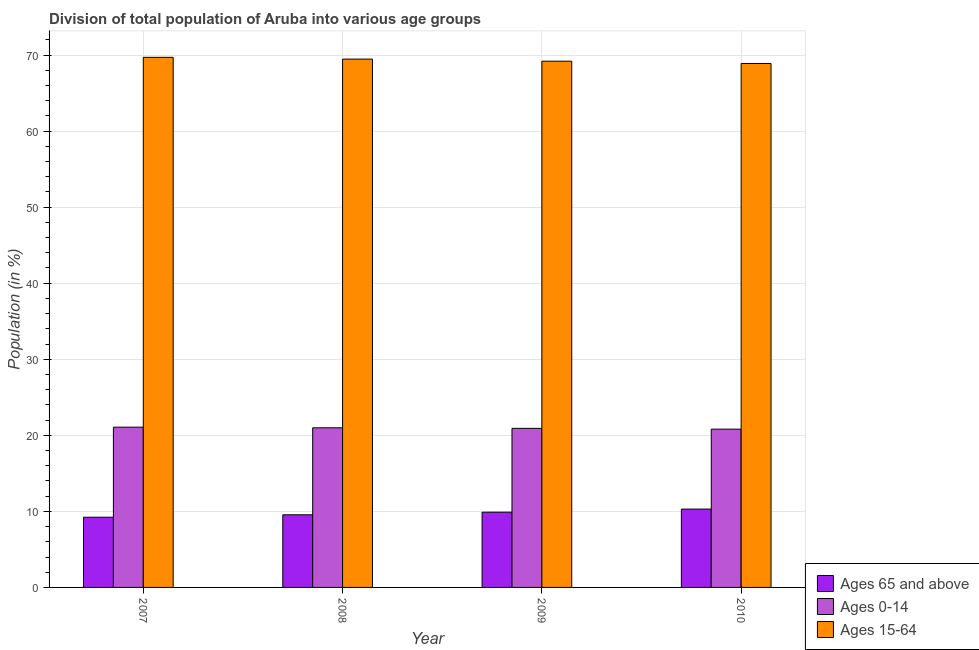How many different coloured bars are there?
Provide a succinct answer. 3. How many groups of bars are there?
Offer a very short reply. 4. How many bars are there on the 1st tick from the left?
Your response must be concise. 3. What is the percentage of population within the age-group 15-64 in 2009?
Provide a succinct answer. 69.19. Across all years, what is the maximum percentage of population within the age-group 0-14?
Ensure brevity in your answer.  21.07. Across all years, what is the minimum percentage of population within the age-group 0-14?
Your response must be concise. 20.81. In which year was the percentage of population within the age-group 15-64 minimum?
Offer a terse response. 2010. What is the total percentage of population within the age-group 0-14 in the graph?
Make the answer very short. 83.78. What is the difference between the percentage of population within the age-group 15-64 in 2008 and that in 2009?
Ensure brevity in your answer.  0.28. What is the difference between the percentage of population within the age-group 0-14 in 2010 and the percentage of population within the age-group of 65 and above in 2007?
Keep it short and to the point. -0.26. What is the average percentage of population within the age-group 15-64 per year?
Your answer should be compact. 69.31. In the year 2010, what is the difference between the percentage of population within the age-group 0-14 and percentage of population within the age-group 15-64?
Offer a terse response. 0. In how many years, is the percentage of population within the age-group 0-14 greater than 68 %?
Give a very brief answer. 0. What is the ratio of the percentage of population within the age-group of 65 and above in 2007 to that in 2008?
Offer a terse response. 0.97. Is the percentage of population within the age-group 15-64 in 2007 less than that in 2010?
Keep it short and to the point. No. What is the difference between the highest and the second highest percentage of population within the age-group of 65 and above?
Ensure brevity in your answer.  0.4. What is the difference between the highest and the lowest percentage of population within the age-group 15-64?
Keep it short and to the point. 0.81. What does the 2nd bar from the left in 2009 represents?
Give a very brief answer. Ages 0-14. What does the 1st bar from the right in 2009 represents?
Make the answer very short. Ages 15-64. Is it the case that in every year, the sum of the percentage of population within the age-group of 65 and above and percentage of population within the age-group 0-14 is greater than the percentage of population within the age-group 15-64?
Your answer should be compact. No. Are all the bars in the graph horizontal?
Give a very brief answer. No. What is the difference between two consecutive major ticks on the Y-axis?
Offer a terse response. 10. Does the graph contain any zero values?
Keep it short and to the point. No. Does the graph contain grids?
Offer a very short reply. Yes. Where does the legend appear in the graph?
Provide a succinct answer. Bottom right. What is the title of the graph?
Keep it short and to the point. Division of total population of Aruba into various age groups
. Does "Czech Republic" appear as one of the legend labels in the graph?
Provide a succinct answer. No. What is the label or title of the Y-axis?
Make the answer very short. Population (in %). What is the Population (in %) in Ages 65 and above in 2007?
Provide a succinct answer. 9.23. What is the Population (in %) in Ages 0-14 in 2007?
Offer a terse response. 21.07. What is the Population (in %) in Ages 15-64 in 2007?
Keep it short and to the point. 69.7. What is the Population (in %) of Ages 65 and above in 2008?
Ensure brevity in your answer.  9.55. What is the Population (in %) of Ages 0-14 in 2008?
Provide a short and direct response. 20.99. What is the Population (in %) in Ages 15-64 in 2008?
Offer a very short reply. 69.46. What is the Population (in %) in Ages 65 and above in 2009?
Offer a terse response. 9.9. What is the Population (in %) of Ages 0-14 in 2009?
Ensure brevity in your answer.  20.91. What is the Population (in %) of Ages 15-64 in 2009?
Ensure brevity in your answer.  69.19. What is the Population (in %) of Ages 65 and above in 2010?
Ensure brevity in your answer.  10.3. What is the Population (in %) of Ages 0-14 in 2010?
Make the answer very short. 20.81. What is the Population (in %) in Ages 15-64 in 2010?
Keep it short and to the point. 68.89. Across all years, what is the maximum Population (in %) of Ages 65 and above?
Offer a very short reply. 10.3. Across all years, what is the maximum Population (in %) of Ages 0-14?
Offer a terse response. 21.07. Across all years, what is the maximum Population (in %) in Ages 15-64?
Offer a terse response. 69.7. Across all years, what is the minimum Population (in %) in Ages 65 and above?
Provide a short and direct response. 9.23. Across all years, what is the minimum Population (in %) in Ages 0-14?
Your answer should be very brief. 20.81. Across all years, what is the minimum Population (in %) of Ages 15-64?
Offer a terse response. 68.89. What is the total Population (in %) in Ages 65 and above in the graph?
Provide a succinct answer. 38.97. What is the total Population (in %) of Ages 0-14 in the graph?
Provide a succinct answer. 83.78. What is the total Population (in %) of Ages 15-64 in the graph?
Ensure brevity in your answer.  277.24. What is the difference between the Population (in %) of Ages 65 and above in 2007 and that in 2008?
Keep it short and to the point. -0.32. What is the difference between the Population (in %) in Ages 0-14 in 2007 and that in 2008?
Provide a short and direct response. 0.09. What is the difference between the Population (in %) in Ages 15-64 in 2007 and that in 2008?
Offer a very short reply. 0.23. What is the difference between the Population (in %) of Ages 65 and above in 2007 and that in 2009?
Offer a terse response. -0.67. What is the difference between the Population (in %) in Ages 0-14 in 2007 and that in 2009?
Offer a very short reply. 0.16. What is the difference between the Population (in %) in Ages 15-64 in 2007 and that in 2009?
Provide a succinct answer. 0.51. What is the difference between the Population (in %) of Ages 65 and above in 2007 and that in 2010?
Provide a short and direct response. -1.07. What is the difference between the Population (in %) of Ages 0-14 in 2007 and that in 2010?
Your answer should be very brief. 0.26. What is the difference between the Population (in %) of Ages 15-64 in 2007 and that in 2010?
Keep it short and to the point. 0.81. What is the difference between the Population (in %) in Ages 65 and above in 2008 and that in 2009?
Make the answer very short. -0.35. What is the difference between the Population (in %) in Ages 0-14 in 2008 and that in 2009?
Keep it short and to the point. 0.07. What is the difference between the Population (in %) in Ages 15-64 in 2008 and that in 2009?
Keep it short and to the point. 0.28. What is the difference between the Population (in %) in Ages 65 and above in 2008 and that in 2010?
Offer a terse response. -0.75. What is the difference between the Population (in %) of Ages 0-14 in 2008 and that in 2010?
Provide a short and direct response. 0.18. What is the difference between the Population (in %) of Ages 15-64 in 2008 and that in 2010?
Offer a very short reply. 0.57. What is the difference between the Population (in %) in Ages 65 and above in 2009 and that in 2010?
Give a very brief answer. -0.4. What is the difference between the Population (in %) of Ages 0-14 in 2009 and that in 2010?
Offer a terse response. 0.11. What is the difference between the Population (in %) in Ages 15-64 in 2009 and that in 2010?
Provide a short and direct response. 0.3. What is the difference between the Population (in %) of Ages 65 and above in 2007 and the Population (in %) of Ages 0-14 in 2008?
Offer a very short reply. -11.76. What is the difference between the Population (in %) in Ages 65 and above in 2007 and the Population (in %) in Ages 15-64 in 2008?
Give a very brief answer. -60.23. What is the difference between the Population (in %) in Ages 0-14 in 2007 and the Population (in %) in Ages 15-64 in 2008?
Provide a succinct answer. -48.39. What is the difference between the Population (in %) in Ages 65 and above in 2007 and the Population (in %) in Ages 0-14 in 2009?
Give a very brief answer. -11.68. What is the difference between the Population (in %) of Ages 65 and above in 2007 and the Population (in %) of Ages 15-64 in 2009?
Give a very brief answer. -59.96. What is the difference between the Population (in %) in Ages 0-14 in 2007 and the Population (in %) in Ages 15-64 in 2009?
Provide a succinct answer. -48.12. What is the difference between the Population (in %) in Ages 65 and above in 2007 and the Population (in %) in Ages 0-14 in 2010?
Your answer should be very brief. -11.58. What is the difference between the Population (in %) of Ages 65 and above in 2007 and the Population (in %) of Ages 15-64 in 2010?
Provide a succinct answer. -59.66. What is the difference between the Population (in %) in Ages 0-14 in 2007 and the Population (in %) in Ages 15-64 in 2010?
Offer a very short reply. -47.82. What is the difference between the Population (in %) in Ages 65 and above in 2008 and the Population (in %) in Ages 0-14 in 2009?
Your response must be concise. -11.37. What is the difference between the Population (in %) in Ages 65 and above in 2008 and the Population (in %) in Ages 15-64 in 2009?
Your answer should be very brief. -59.64. What is the difference between the Population (in %) in Ages 0-14 in 2008 and the Population (in %) in Ages 15-64 in 2009?
Keep it short and to the point. -48.2. What is the difference between the Population (in %) of Ages 65 and above in 2008 and the Population (in %) of Ages 0-14 in 2010?
Your response must be concise. -11.26. What is the difference between the Population (in %) in Ages 65 and above in 2008 and the Population (in %) in Ages 15-64 in 2010?
Give a very brief answer. -59.34. What is the difference between the Population (in %) in Ages 0-14 in 2008 and the Population (in %) in Ages 15-64 in 2010?
Your answer should be compact. -47.9. What is the difference between the Population (in %) of Ages 65 and above in 2009 and the Population (in %) of Ages 0-14 in 2010?
Ensure brevity in your answer.  -10.91. What is the difference between the Population (in %) of Ages 65 and above in 2009 and the Population (in %) of Ages 15-64 in 2010?
Offer a very short reply. -58.99. What is the difference between the Population (in %) of Ages 0-14 in 2009 and the Population (in %) of Ages 15-64 in 2010?
Offer a terse response. -47.98. What is the average Population (in %) of Ages 65 and above per year?
Your answer should be very brief. 9.74. What is the average Population (in %) of Ages 0-14 per year?
Offer a very short reply. 20.95. What is the average Population (in %) in Ages 15-64 per year?
Offer a very short reply. 69.31. In the year 2007, what is the difference between the Population (in %) in Ages 65 and above and Population (in %) in Ages 0-14?
Provide a succinct answer. -11.84. In the year 2007, what is the difference between the Population (in %) in Ages 65 and above and Population (in %) in Ages 15-64?
Ensure brevity in your answer.  -60.47. In the year 2007, what is the difference between the Population (in %) of Ages 0-14 and Population (in %) of Ages 15-64?
Offer a very short reply. -48.63. In the year 2008, what is the difference between the Population (in %) of Ages 65 and above and Population (in %) of Ages 0-14?
Your answer should be very brief. -11.44. In the year 2008, what is the difference between the Population (in %) in Ages 65 and above and Population (in %) in Ages 15-64?
Your answer should be very brief. -59.92. In the year 2008, what is the difference between the Population (in %) of Ages 0-14 and Population (in %) of Ages 15-64?
Your answer should be very brief. -48.48. In the year 2009, what is the difference between the Population (in %) in Ages 65 and above and Population (in %) in Ages 0-14?
Ensure brevity in your answer.  -11.02. In the year 2009, what is the difference between the Population (in %) of Ages 65 and above and Population (in %) of Ages 15-64?
Your answer should be compact. -59.29. In the year 2009, what is the difference between the Population (in %) in Ages 0-14 and Population (in %) in Ages 15-64?
Offer a very short reply. -48.27. In the year 2010, what is the difference between the Population (in %) of Ages 65 and above and Population (in %) of Ages 0-14?
Offer a very short reply. -10.51. In the year 2010, what is the difference between the Population (in %) in Ages 65 and above and Population (in %) in Ages 15-64?
Give a very brief answer. -58.59. In the year 2010, what is the difference between the Population (in %) in Ages 0-14 and Population (in %) in Ages 15-64?
Ensure brevity in your answer.  -48.08. What is the ratio of the Population (in %) of Ages 65 and above in 2007 to that in 2008?
Your response must be concise. 0.97. What is the ratio of the Population (in %) of Ages 15-64 in 2007 to that in 2008?
Your response must be concise. 1. What is the ratio of the Population (in %) in Ages 65 and above in 2007 to that in 2009?
Make the answer very short. 0.93. What is the ratio of the Population (in %) in Ages 0-14 in 2007 to that in 2009?
Provide a succinct answer. 1.01. What is the ratio of the Population (in %) of Ages 15-64 in 2007 to that in 2009?
Provide a short and direct response. 1.01. What is the ratio of the Population (in %) in Ages 65 and above in 2007 to that in 2010?
Provide a succinct answer. 0.9. What is the ratio of the Population (in %) of Ages 0-14 in 2007 to that in 2010?
Make the answer very short. 1.01. What is the ratio of the Population (in %) in Ages 15-64 in 2007 to that in 2010?
Give a very brief answer. 1.01. What is the ratio of the Population (in %) of Ages 65 and above in 2008 to that in 2009?
Your answer should be very brief. 0.96. What is the ratio of the Population (in %) of Ages 0-14 in 2008 to that in 2009?
Provide a succinct answer. 1. What is the ratio of the Population (in %) in Ages 65 and above in 2008 to that in 2010?
Your answer should be very brief. 0.93. What is the ratio of the Population (in %) of Ages 0-14 in 2008 to that in 2010?
Your response must be concise. 1.01. What is the ratio of the Population (in %) in Ages 15-64 in 2008 to that in 2010?
Provide a short and direct response. 1.01. What is the ratio of the Population (in %) of Ages 65 and above in 2009 to that in 2010?
Keep it short and to the point. 0.96. What is the ratio of the Population (in %) of Ages 0-14 in 2009 to that in 2010?
Provide a succinct answer. 1.01. What is the ratio of the Population (in %) of Ages 15-64 in 2009 to that in 2010?
Your answer should be very brief. 1. What is the difference between the highest and the second highest Population (in %) of Ages 65 and above?
Offer a very short reply. 0.4. What is the difference between the highest and the second highest Population (in %) of Ages 0-14?
Provide a short and direct response. 0.09. What is the difference between the highest and the second highest Population (in %) in Ages 15-64?
Offer a terse response. 0.23. What is the difference between the highest and the lowest Population (in %) of Ages 65 and above?
Ensure brevity in your answer.  1.07. What is the difference between the highest and the lowest Population (in %) of Ages 0-14?
Offer a terse response. 0.26. What is the difference between the highest and the lowest Population (in %) in Ages 15-64?
Offer a terse response. 0.81. 